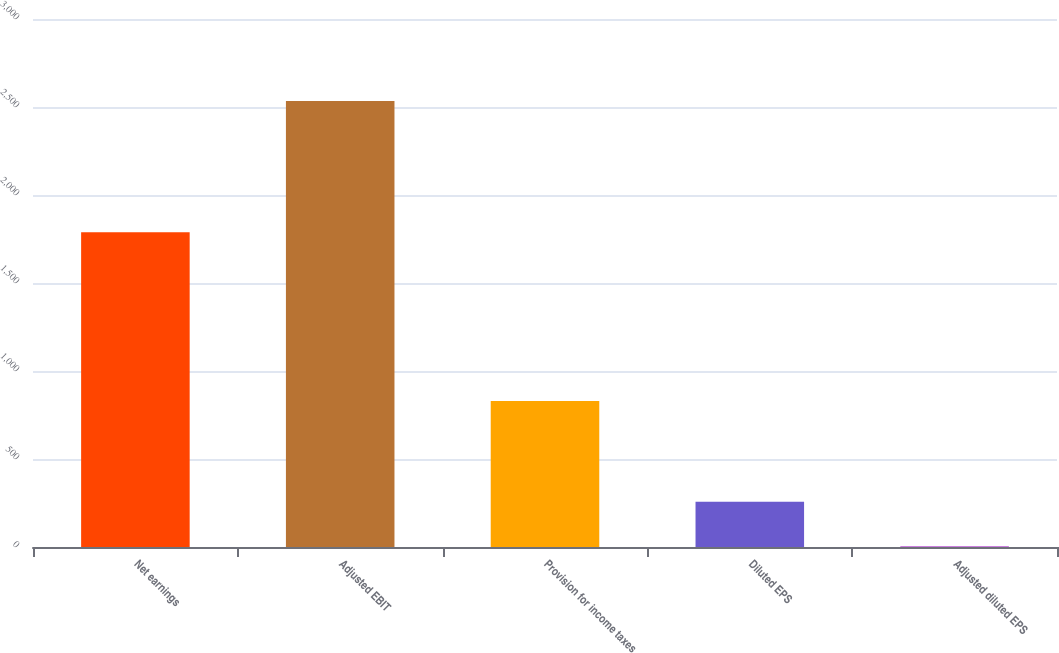Convert chart to OTSL. <chart><loc_0><loc_0><loc_500><loc_500><bar_chart><fcel>Net earnings<fcel>Adjusted EBIT<fcel>Provision for income taxes<fcel>Diluted EPS<fcel>Adjusted diluted EPS<nl><fcel>1787.8<fcel>2533.4<fcel>829.1<fcel>256.78<fcel>3.82<nl></chart> 